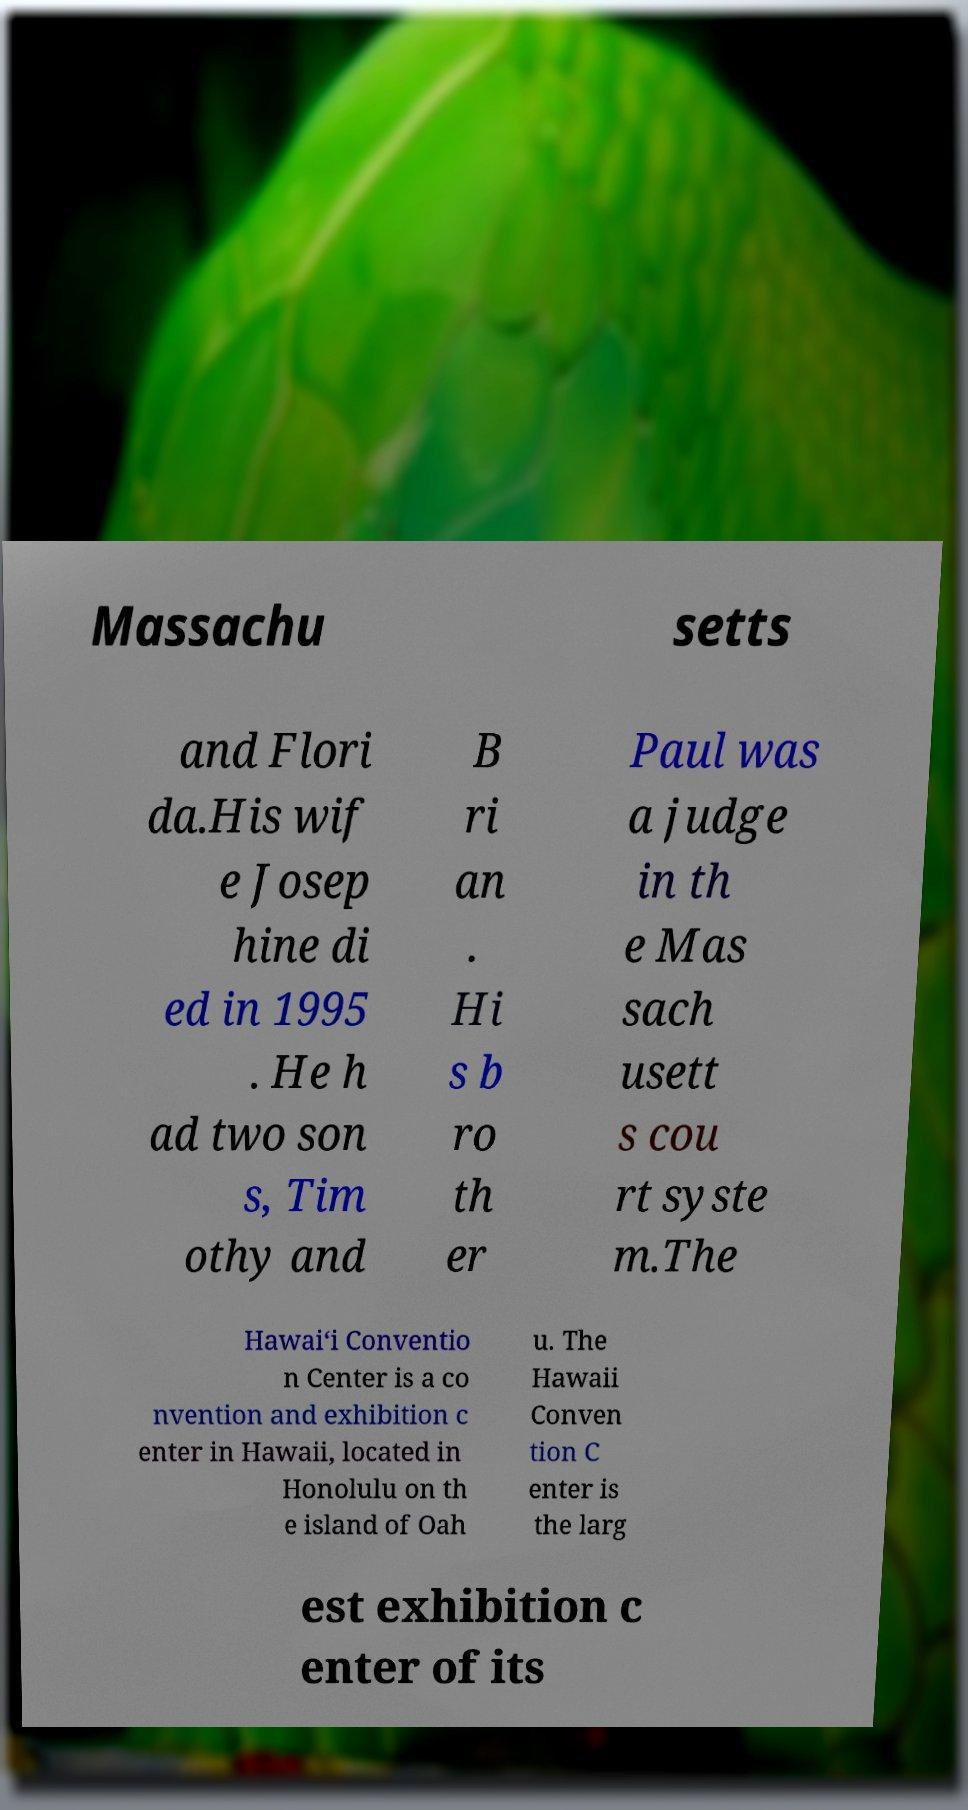I need the written content from this picture converted into text. Can you do that? Massachu setts and Flori da.His wif e Josep hine di ed in 1995 . He h ad two son s, Tim othy and B ri an . Hi s b ro th er Paul was a judge in th e Mas sach usett s cou rt syste m.The Hawai‘i Conventio n Center is a co nvention and exhibition c enter in Hawaii, located in Honolulu on th e island of Oah u. The Hawaii Conven tion C enter is the larg est exhibition c enter of its 